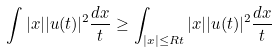Convert formula to latex. <formula><loc_0><loc_0><loc_500><loc_500>\int | x | | u ( t ) | ^ { 2 } \frac { d x } t \geq \int _ { | x | \leq R t } | x | | u ( t ) | ^ { 2 } \frac { d x } t</formula> 